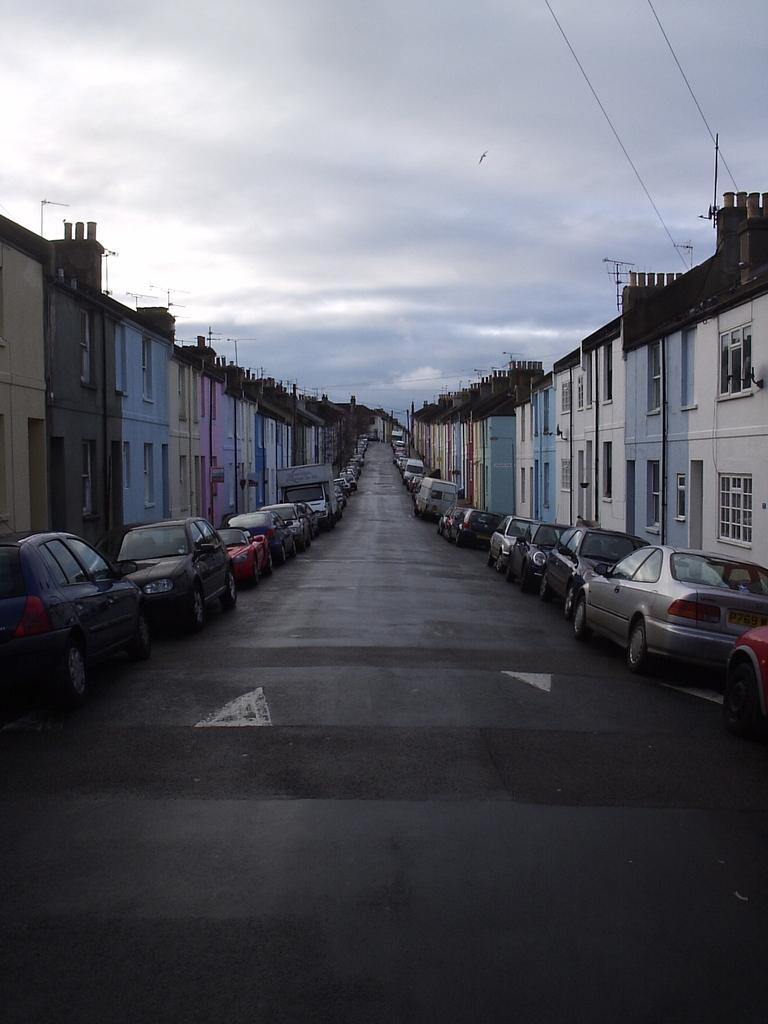What type of view is shown in the image? The image is an outside view. What can be seen at the bottom of the image? There is a road at the bottom of the image. How many cars are visible on both sides of the road? There are many cars on both sides of the road. What structures are present on both sides of the road? There are buildings on both sides of the road. What is visible at the top of the image? The sky is visible at the top of the image. What can be observed in the sky? Clouds are present in the sky. Where is the bomb located in the image? There is no bomb present in the image. What type of pin is visible on the buildings in the image? There is no pin visible on the buildings in the image. 